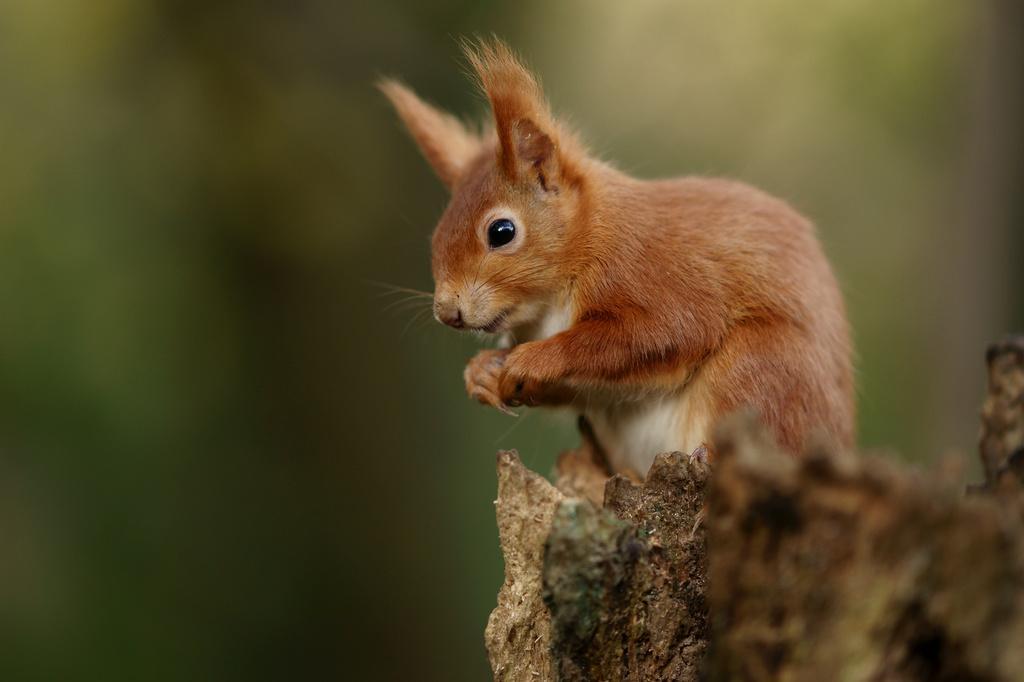In one or two sentences, can you explain what this image depicts? In the image there is a brown squirrel standing on bark of a tree and the background is blurry. 